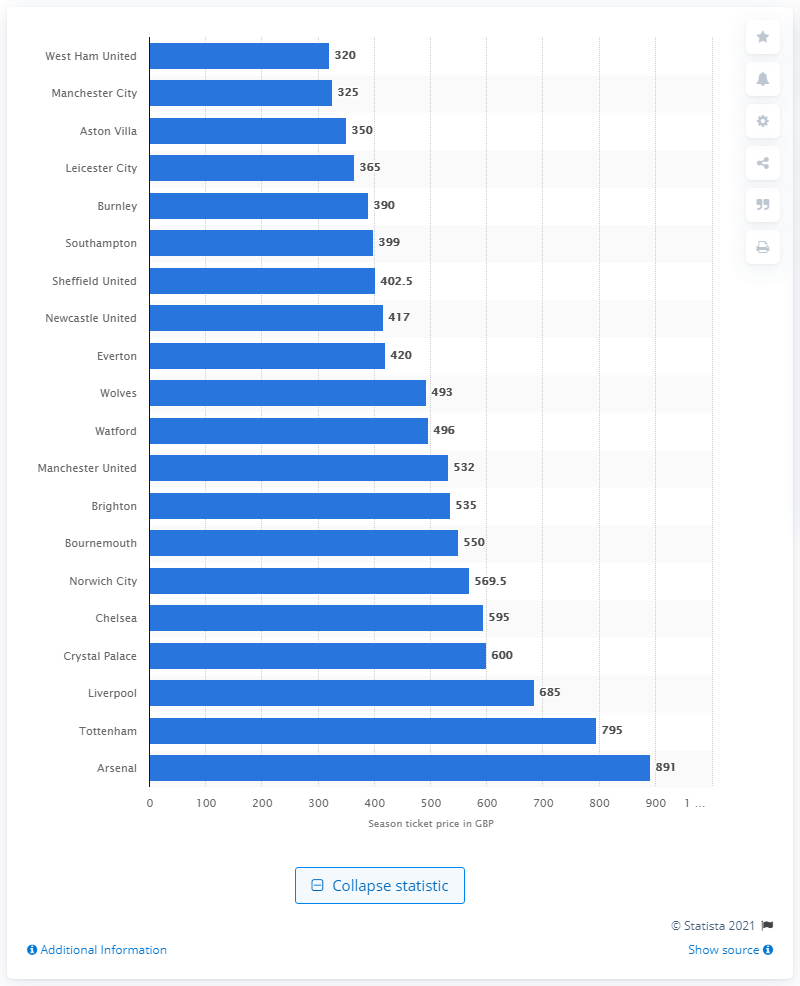Indicate a few pertinent items in this graphic. The team with the cheapest season ticket costing 795 British pounds is Tottenham. Manchester City is the team that sells the most expensive season ticket for 325 British pounds. 